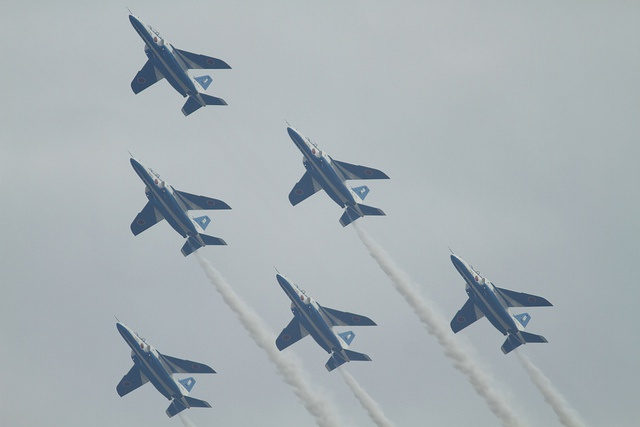Describe the objects in this image and their specific colors. I can see airplane in darkgray, blue, and gray tones, airplane in darkgray, blue, and gray tones, airplane in darkgray, blue, and gray tones, airplane in darkgray, gray, and blue tones, and airplane in darkgray, gray, and blue tones in this image. 